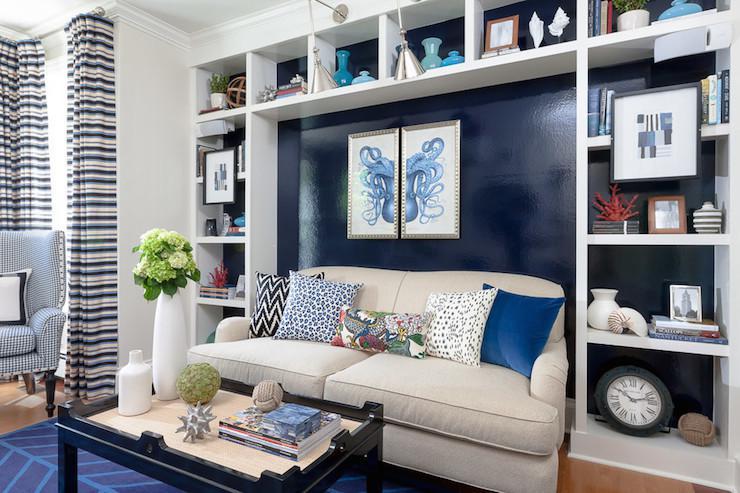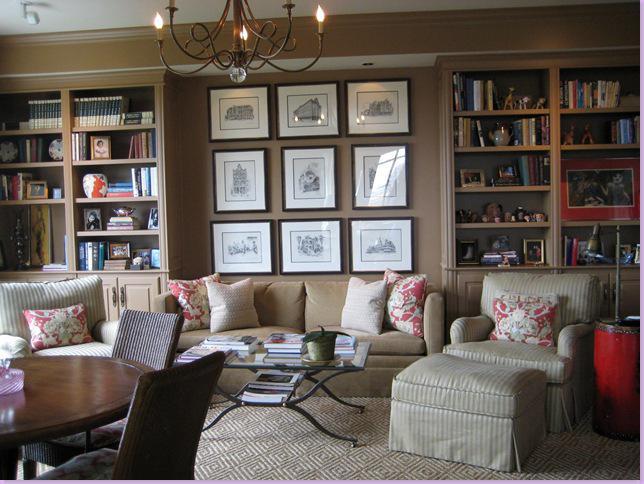The first image is the image on the left, the second image is the image on the right. Considering the images on both sides, is "One of the sofas has no coffee table before it in one of the images." valid? Answer yes or no. No. The first image is the image on the left, the second image is the image on the right. Evaluate the accuracy of this statement regarding the images: "Each image shows a single piece of art mounted on the wall behind a sofa flanked by bookshelves.". Is it true? Answer yes or no. No. 